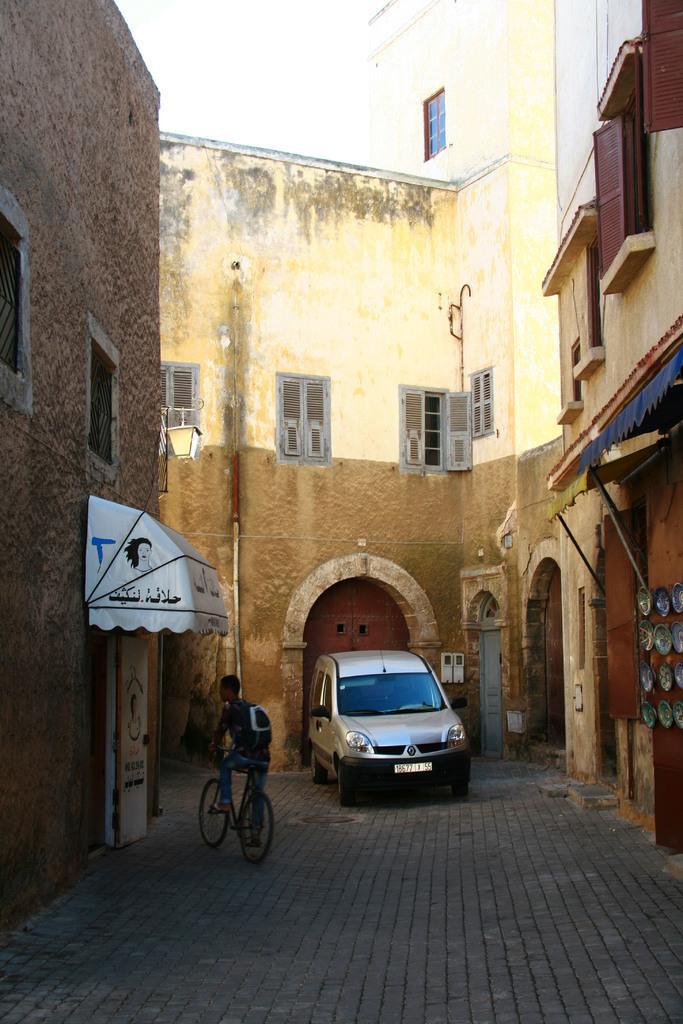What type of structures can be seen in the image? There are buildings in the image. What is located in front of a door in the image? There is a vehicle in front of a door in the image. What mode of transportation is being used by the person at the bottom of the image? The person at the bottom of the image is riding a bicycle. What type of silk is being used to decorate the buildings in the image? There is no silk present in the image, and the buildings are not being decorated with silk. Can you see any rabbits in the image? There are no rabbits present in the image. 